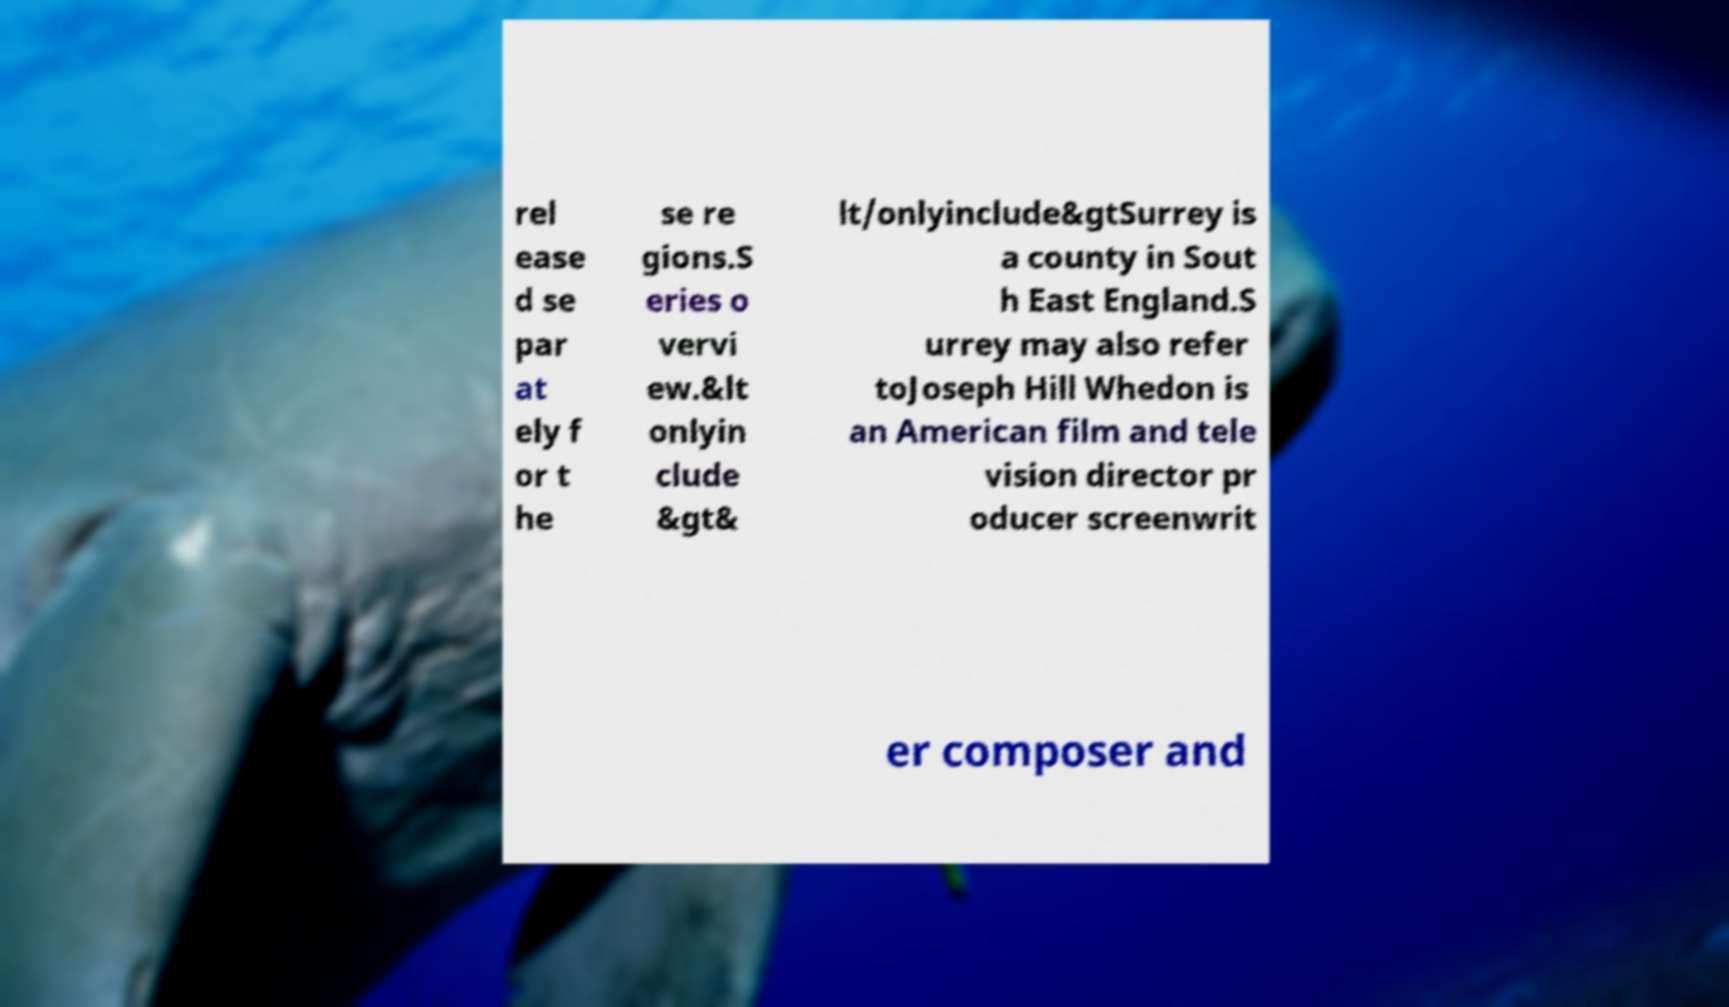There's text embedded in this image that I need extracted. Can you transcribe it verbatim? rel ease d se par at ely f or t he se re gions.S eries o vervi ew.&lt onlyin clude &gt& lt/onlyinclude&gtSurrey is a county in Sout h East England.S urrey may also refer toJoseph Hill Whedon is an American film and tele vision director pr oducer screenwrit er composer and 